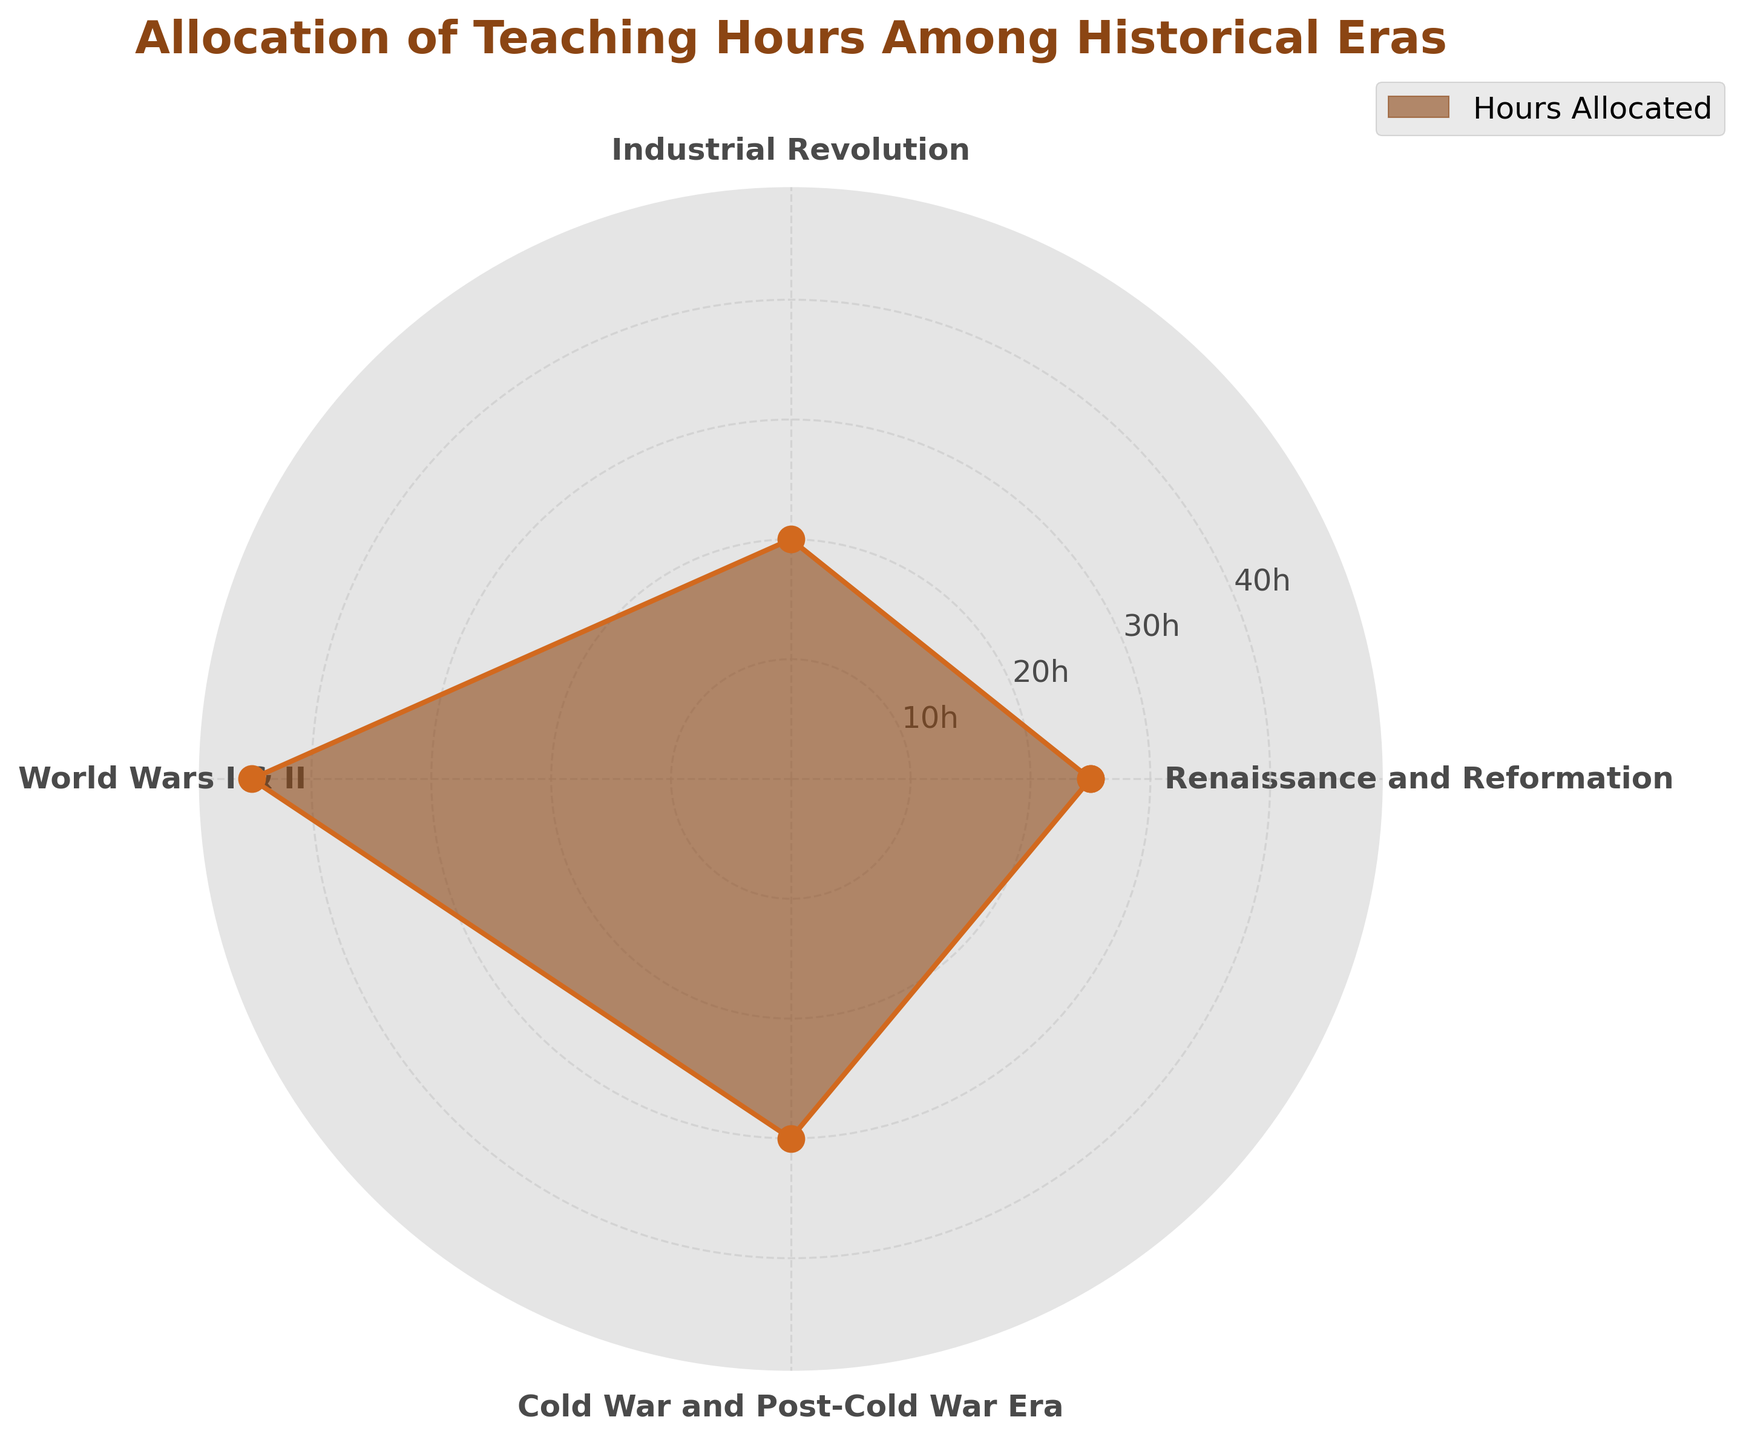What's the title of the chart? The title is prominently placed at the top of the chart, using a large and bold font for emphasis.
Answer: Allocation of Teaching Hours Among Historical Eras What does the radial axis represent? The radial axis measures the hours allocated for each historical era. This is indicated by the labels in hours (h) along the radial axis.
Answer: Hours allocated How many historical eras are represented in the chart? There are five data points plotted, each marked by radial axes with corresponding labels on the outer ring. This matches the five historical eras listed in the data.
Answer: Four Which historical era has the highest allocation of teaching hours? The World Wars I & II era is associated with the largest radius from the center, indicating it has the highest number of hours allocated.
Answer: World Wars I & II What is the difference in teaching hours between the era with the highest and the lowest allocation? The era with the highest allocation is World Wars I & II with 45 hours, and the era with the lowest is the Industrial Revolution with 20 hours. The difference is calculated as 45 - 20.
Answer: 25 hours Which two eras have a combined allocation of 45 hours? Renaissance and Reformation has 25 hours, and the Industrial Revolution has 20 hours. Adding these two values gives a total of 45 hours.
Answer: Renaissance and Reformation and Industrial Revolution Between which two eras is the smallest change in hours allocated? By comparing pairs of adjacent data points, the smallest change is between the Cold War and Post-Cold War Era (30 hours) and the Industrial Revolution (20 hours), with a difference of 30 - 20.
Answer: Cold War and Post-Cold War Era and Industrial Revolution Which has more hours allocated, the Renaissance and Reformation or the Cold War and Post-Cold War Era? By how much? The Renaissance and Reformation has 25 hours allocated, while the Cold War and Post-Cold War Era has 30 hours. The difference is 30 - 25.
Answer: Cold War and Post-Cold War Era by 5 hours If the hours were to be evenly distributed among the four eras, how many hours would each era get? The total hours allocated is the sum of hours across all eras: 25 + 20 + 45 + 30 = 120 hours. Dividing by 4 gives 120 / 4.
Answer: 30 hours Label each era with its exact numeric value for hours in the chart. Which era would have the smallest value, and what is it? The chart's labels would show that the Industrial Revolution has the smallest allocated hours at 20.
Answer: Industrial Revolution with 20 hours 